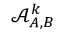Convert formula to latex. <formula><loc_0><loc_0><loc_500><loc_500>\mathcal { A } _ { A , B } ^ { k }</formula> 